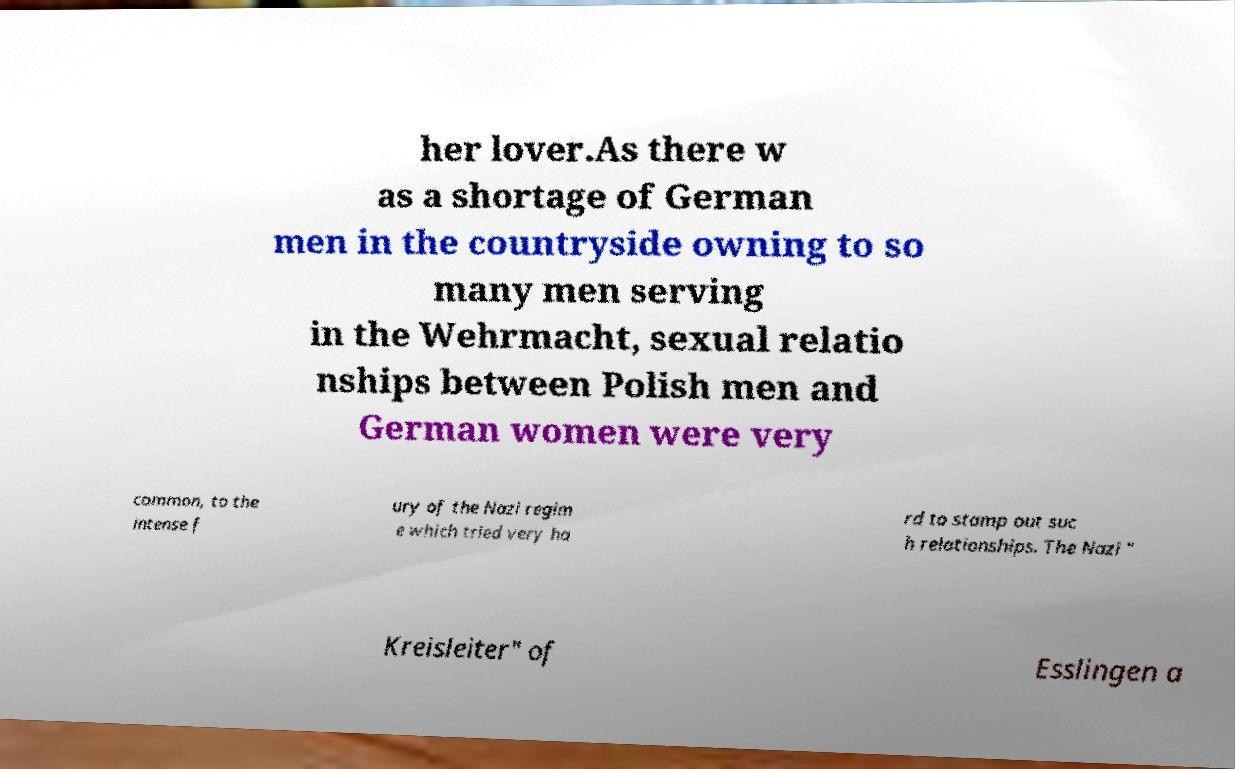There's text embedded in this image that I need extracted. Can you transcribe it verbatim? her lover.As there w as a shortage of German men in the countryside owning to so many men serving in the Wehrmacht, sexual relatio nships between Polish men and German women were very common, to the intense f ury of the Nazi regim e which tried very ha rd to stamp out suc h relationships. The Nazi " Kreisleiter" of Esslingen a 